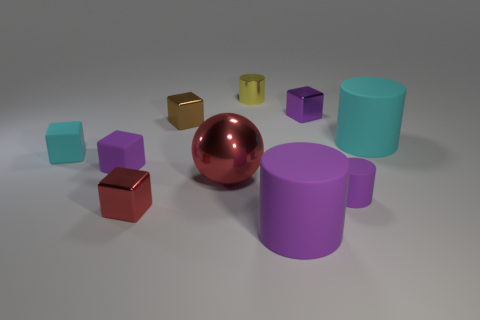Subtract all small purple blocks. How many blocks are left? 3 Subtract all red cylinders. How many purple cubes are left? 2 Subtract all cyan cylinders. How many cylinders are left? 3 Subtract 0 green cubes. How many objects are left? 10 Subtract all balls. How many objects are left? 9 Subtract 1 cylinders. How many cylinders are left? 3 Subtract all brown balls. Subtract all brown cubes. How many balls are left? 1 Subtract all large blue metal spheres. Subtract all red metal things. How many objects are left? 8 Add 9 purple shiny blocks. How many purple shiny blocks are left? 10 Add 5 small brown metallic objects. How many small brown metallic objects exist? 6 